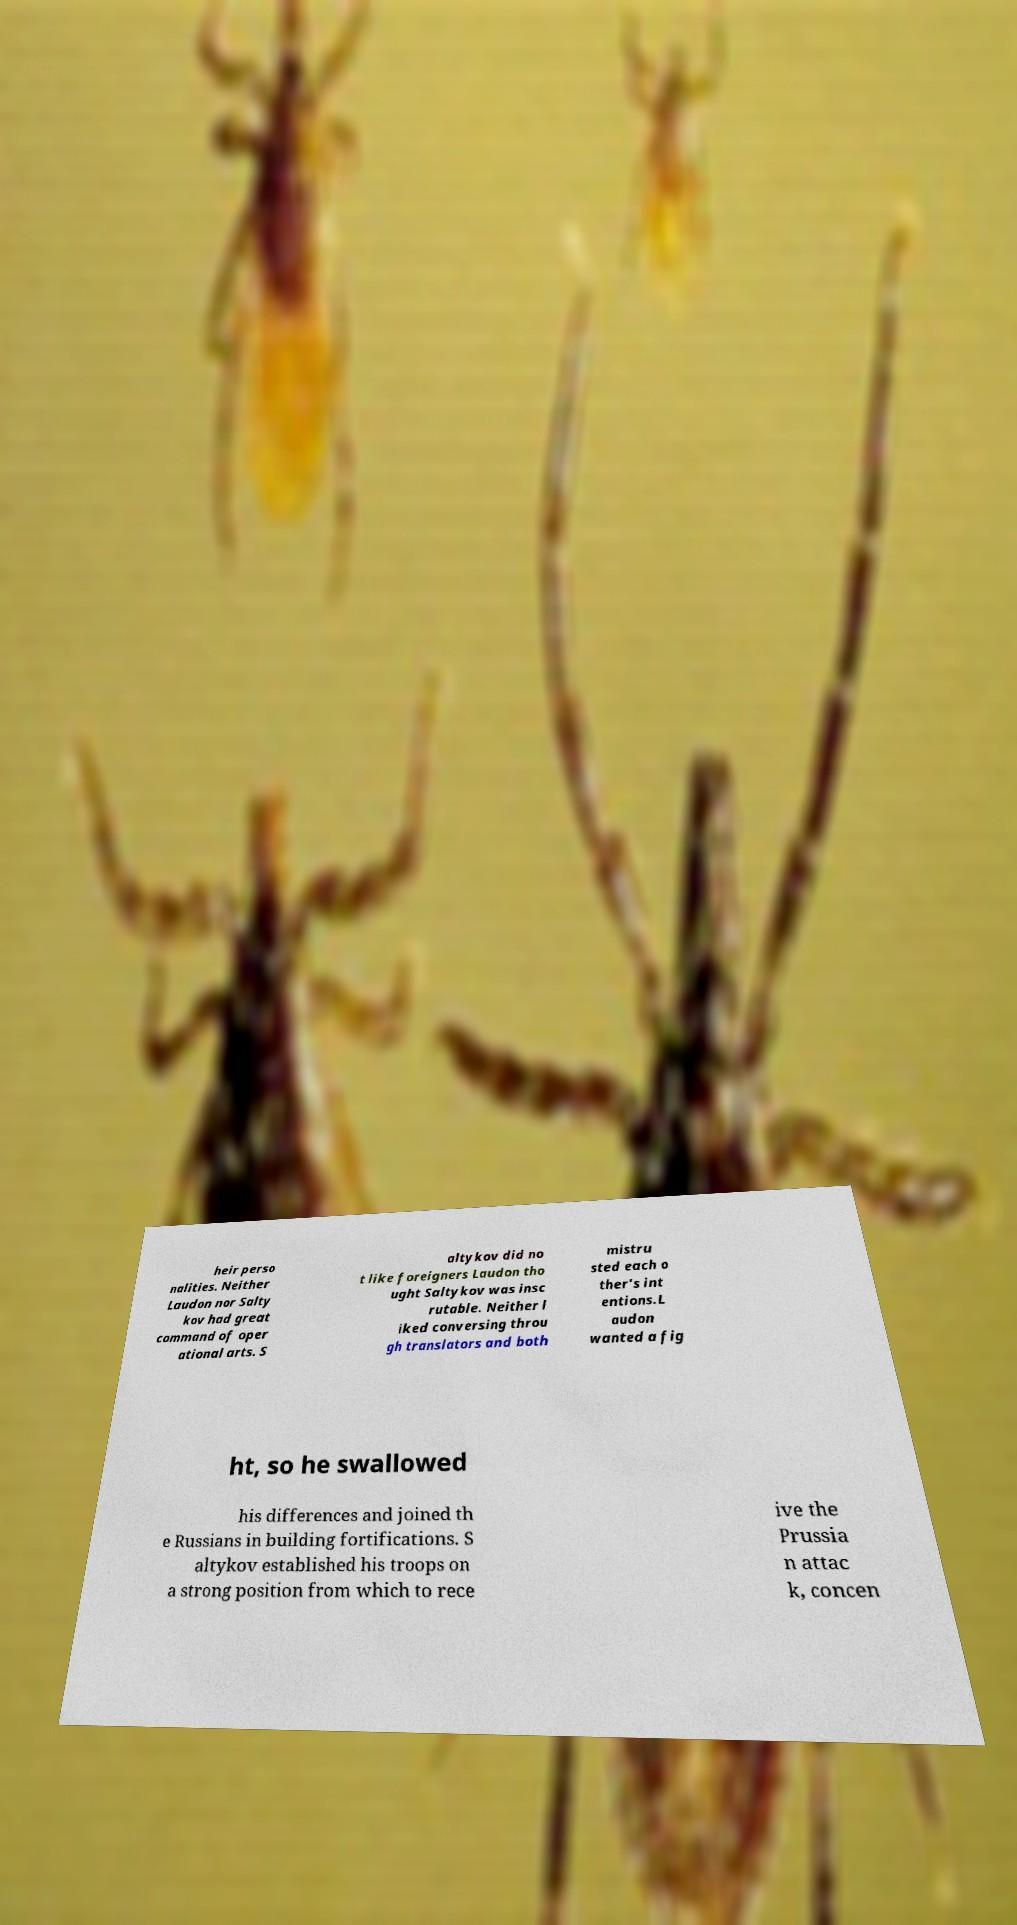Please identify and transcribe the text found in this image. heir perso nalities. Neither Laudon nor Salty kov had great command of oper ational arts. S altykov did no t like foreigners Laudon tho ught Saltykov was insc rutable. Neither l iked conversing throu gh translators and both mistru sted each o ther's int entions.L audon wanted a fig ht, so he swallowed his differences and joined th e Russians in building fortifications. S altykov established his troops on a strong position from which to rece ive the Prussia n attac k, concen 